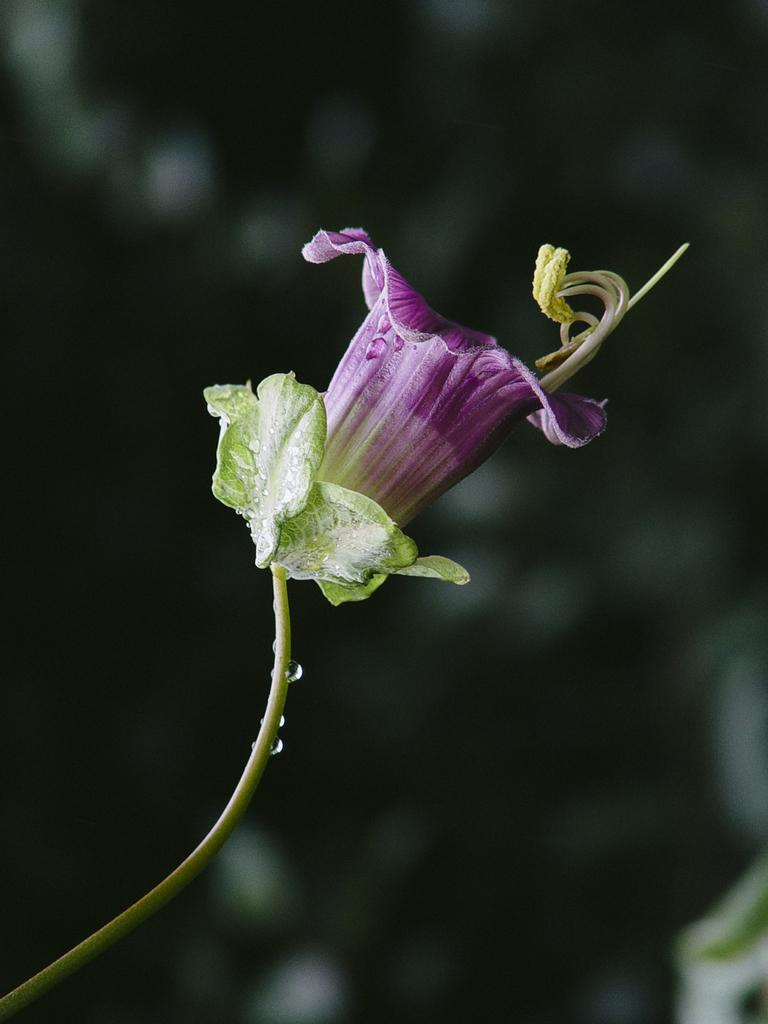What colors are present in the flower in the image? The flower in the image has purple and green colors. Can you describe any other stage of the flower's growth in the image? Yes, there is a flower bud in the image. How would you describe the background of the image? The background of the image is blurred. What type of humor can be seen in the picture in the image? There is no picture present in the image, only a flower and a flower bud. Can you tell me who the flower has a crush on in the image? Flowers do not have emotions or the ability to have crushes, so this cannot be determined from the image. 